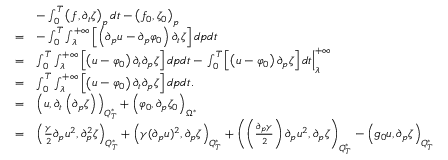<formula> <loc_0><loc_0><loc_500><loc_500>\begin{array} { r l } & { - \int _ { 0 } ^ { T } \left ( f , \partial _ { t } \zeta \right ) _ { p } d t - \left ( f _ { 0 } , \zeta _ { 0 } \right ) _ { p } } \\ { = } & { - \int _ { 0 } ^ { T } \int _ { \lambda } ^ { + \infty } \left [ \left ( \partial _ { p } u - \partial _ { p } \varphi _ { 0 } \right ) \partial _ { t } \zeta \right ] d p d t } \\ { = } & { \int _ { 0 } ^ { T } \int _ { \lambda } ^ { + \infty } \left [ \left ( u - \varphi _ { 0 } \right ) \partial _ { t } \partial _ { p } \zeta \right ] d p d t - \int _ { 0 } ^ { T } \left [ \left ( u - \varphi _ { 0 } \right ) \partial _ { p } \zeta \right ] d t \right | _ { \lambda } ^ { + \infty } } \\ { = } & { \int _ { 0 } ^ { T } \int _ { \lambda } ^ { + \infty } \left [ \left ( u - \varphi _ { 0 } \right ) \partial _ { t } \partial _ { p } \zeta \right ] d p d t . } \\ { = } & { \left ( u , \partial _ { t } \left ( \partial _ { p } \zeta \right ) \right ) _ { Q _ { T } ^ { * } } + \left ( \varphi _ { 0 } , \partial _ { p } \zeta _ { 0 } \right ) _ { \Omega ^ { * } } } \\ { = } & { \left ( \frac { \gamma } { 2 } \partial _ { p } u ^ { 2 } , \partial _ { p } ^ { 2 } \zeta \right ) _ { Q _ { T } ^ { * } } + \left ( \gamma ( \partial _ { p } u ) ^ { 2 } , \partial _ { p } \zeta \right ) _ { Q _ { T } ^ { * } } + \left ( \left ( \frac { \partial _ { p } \gamma } { 2 } \right ) \partial _ { p } u ^ { 2 } , \partial _ { p } \zeta \right ) _ { Q _ { T } ^ { * } } - \left ( g _ { 0 } u , \partial _ { p } \zeta \right ) _ { Q _ { T } ^ { * } } } \end{array}</formula> 